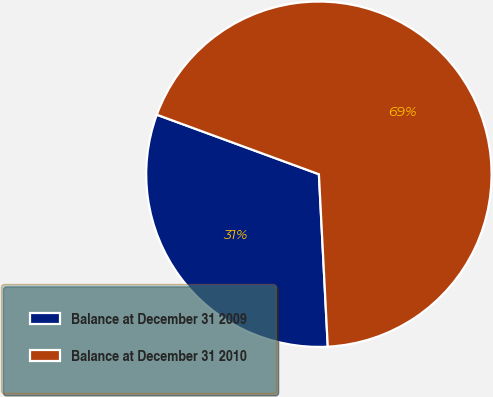Convert chart to OTSL. <chart><loc_0><loc_0><loc_500><loc_500><pie_chart><fcel>Balance at December 31 2009<fcel>Balance at December 31 2010<nl><fcel>31.42%<fcel>68.58%<nl></chart> 